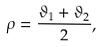<formula> <loc_0><loc_0><loc_500><loc_500>\rho = \frac { \vartheta _ { 1 } + \vartheta _ { 2 } } { 2 } ,</formula> 